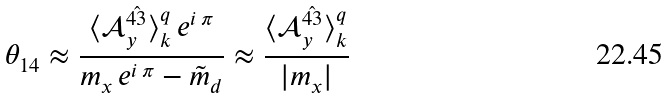Convert formula to latex. <formula><loc_0><loc_0><loc_500><loc_500>\theta _ { 1 4 } \approx \frac { \langle \mathcal { A } _ { y } ^ { \hat { 4 3 } } \rangle ^ { q } _ { k } \, e ^ { i \, \pi } } { m _ { x } \, e ^ { i \, \pi } - \tilde { m } _ { d } } \approx \frac { \langle \mathcal { A } _ { y } ^ { \hat { 4 3 } } \rangle ^ { q } _ { k } } { | m _ { x } | }</formula> 